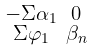Convert formula to latex. <formula><loc_0><loc_0><loc_500><loc_500>\begin{smallmatrix} - \Sigma \alpha _ { 1 } & 0 \\ \Sigma \varphi _ { 1 } & \beta _ { n } \end{smallmatrix}</formula> 